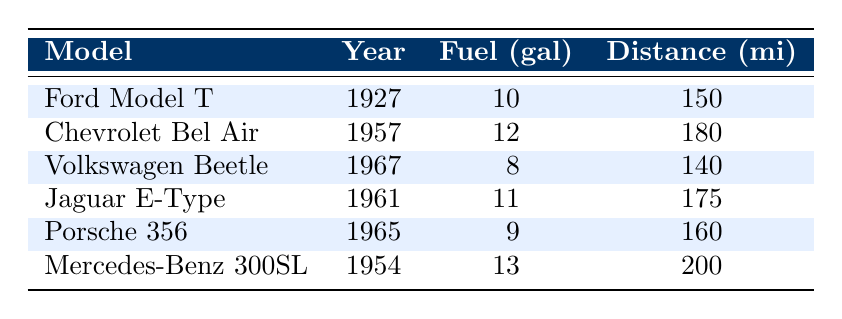What is the fuel consumed by the Mercedes-Benz 300SL? The table shows the entries for each car model, and for the Mercedes-Benz 300SL, the fuel consumed is listed as 13 gallons.
Answer: 13 gallons Which vintage car traveled the furthest distance? By examining the 'Distance Traveled' column, the largest value is 200 miles for the Mercedes-Benz 300SL.
Answer: Mercedes-Benz 300SL What is the total fuel consumed by all the vintage cars? To find the total fuel consumed, sum all the values in the 'Fuel (gal)' column: 10 + 12 + 8 + 11 + 9 + 13 = 63 gallons.
Answer: 63 gallons Did the Jaguar E-Type consume more fuel than the Chevrolet Bel Air? Comparing the fuel consumed: the Jaguar E-Type used 11 gallons, while the Chevrolet Bel Air used 12 gallons. Thus, it consumed less.
Answer: No What is the average distance traveled by the vintage cars? To find the average, sum all the distances: 150 + 180 + 140 + 175 + 160 + 200 = 1,005 miles. Then divide by the number of cars (6): 1,005 / 6 ≈ 167.5 miles.
Answer: 167.5 miles Which car used the least amount of fuel? Looking at the 'Fuel (gal)' column, the smallest value is 8 gallons for the Volkswagen Beetle.
Answer: Volkswagen Beetle What is the difference in distance traveled between the Ford Model T and the Porsche 356? The Ford Model T traveled 150 miles and the Porsche 356 traveled 160 miles. The difference is 160 - 150 = 10 miles.
Answer: 10 miles Is it true that all cars consumed more than 7 gallons of fuel? Checking each value in the 'Fuel (gal)' column: all cars have values greater than 7 gallons, confirming the statement is true.
Answer: Yes Find the average fuel consumption of the listed vintage cars. To calculate the average fuel consumption, first sum the fuel values (10 + 12 + 8 + 11 + 9 + 13 = 63 gallons), then divide by the number of cars (6): 63 / 6 = 10.5 gallons.
Answer: 10.5 gallons 